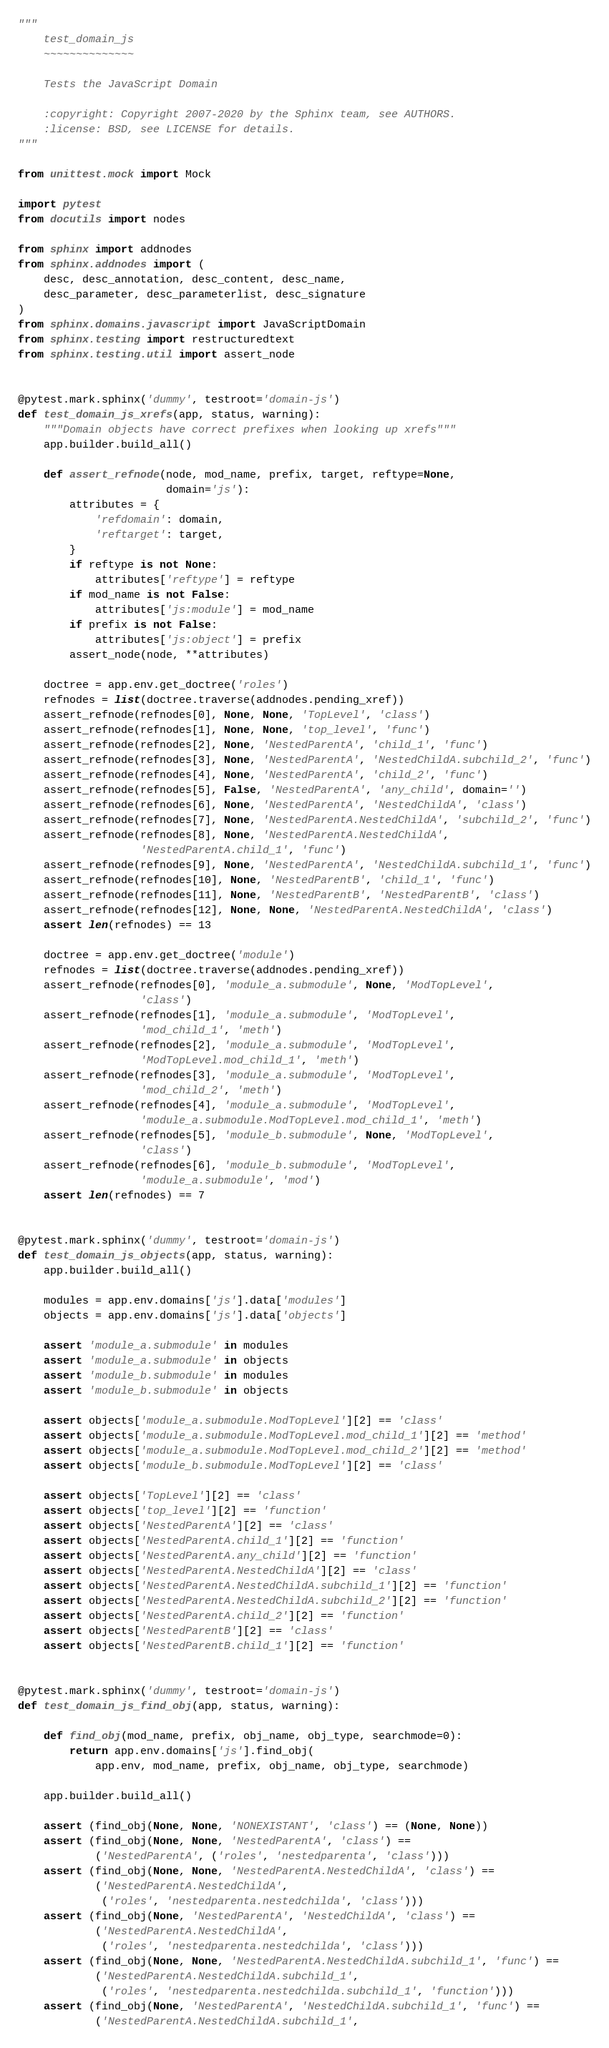<code> <loc_0><loc_0><loc_500><loc_500><_Python_>"""
    test_domain_js
    ~~~~~~~~~~~~~~

    Tests the JavaScript Domain

    :copyright: Copyright 2007-2020 by the Sphinx team, see AUTHORS.
    :license: BSD, see LICENSE for details.
"""

from unittest.mock import Mock

import pytest
from docutils import nodes

from sphinx import addnodes
from sphinx.addnodes import (
    desc, desc_annotation, desc_content, desc_name,
    desc_parameter, desc_parameterlist, desc_signature
)
from sphinx.domains.javascript import JavaScriptDomain
from sphinx.testing import restructuredtext
from sphinx.testing.util import assert_node


@pytest.mark.sphinx('dummy', testroot='domain-js')
def test_domain_js_xrefs(app, status, warning):
    """Domain objects have correct prefixes when looking up xrefs"""
    app.builder.build_all()

    def assert_refnode(node, mod_name, prefix, target, reftype=None,
                       domain='js'):
        attributes = {
            'refdomain': domain,
            'reftarget': target,
        }
        if reftype is not None:
            attributes['reftype'] = reftype
        if mod_name is not False:
            attributes['js:module'] = mod_name
        if prefix is not False:
            attributes['js:object'] = prefix
        assert_node(node, **attributes)

    doctree = app.env.get_doctree('roles')
    refnodes = list(doctree.traverse(addnodes.pending_xref))
    assert_refnode(refnodes[0], None, None, 'TopLevel', 'class')
    assert_refnode(refnodes[1], None, None, 'top_level', 'func')
    assert_refnode(refnodes[2], None, 'NestedParentA', 'child_1', 'func')
    assert_refnode(refnodes[3], None, 'NestedParentA', 'NestedChildA.subchild_2', 'func')
    assert_refnode(refnodes[4], None, 'NestedParentA', 'child_2', 'func')
    assert_refnode(refnodes[5], False, 'NestedParentA', 'any_child', domain='')
    assert_refnode(refnodes[6], None, 'NestedParentA', 'NestedChildA', 'class')
    assert_refnode(refnodes[7], None, 'NestedParentA.NestedChildA', 'subchild_2', 'func')
    assert_refnode(refnodes[8], None, 'NestedParentA.NestedChildA',
                   'NestedParentA.child_1', 'func')
    assert_refnode(refnodes[9], None, 'NestedParentA', 'NestedChildA.subchild_1', 'func')
    assert_refnode(refnodes[10], None, 'NestedParentB', 'child_1', 'func')
    assert_refnode(refnodes[11], None, 'NestedParentB', 'NestedParentB', 'class')
    assert_refnode(refnodes[12], None, None, 'NestedParentA.NestedChildA', 'class')
    assert len(refnodes) == 13

    doctree = app.env.get_doctree('module')
    refnodes = list(doctree.traverse(addnodes.pending_xref))
    assert_refnode(refnodes[0], 'module_a.submodule', None, 'ModTopLevel',
                   'class')
    assert_refnode(refnodes[1], 'module_a.submodule', 'ModTopLevel',
                   'mod_child_1', 'meth')
    assert_refnode(refnodes[2], 'module_a.submodule', 'ModTopLevel',
                   'ModTopLevel.mod_child_1', 'meth')
    assert_refnode(refnodes[3], 'module_a.submodule', 'ModTopLevel',
                   'mod_child_2', 'meth')
    assert_refnode(refnodes[4], 'module_a.submodule', 'ModTopLevel',
                   'module_a.submodule.ModTopLevel.mod_child_1', 'meth')
    assert_refnode(refnodes[5], 'module_b.submodule', None, 'ModTopLevel',
                   'class')
    assert_refnode(refnodes[6], 'module_b.submodule', 'ModTopLevel',
                   'module_a.submodule', 'mod')
    assert len(refnodes) == 7


@pytest.mark.sphinx('dummy', testroot='domain-js')
def test_domain_js_objects(app, status, warning):
    app.builder.build_all()

    modules = app.env.domains['js'].data['modules']
    objects = app.env.domains['js'].data['objects']

    assert 'module_a.submodule' in modules
    assert 'module_a.submodule' in objects
    assert 'module_b.submodule' in modules
    assert 'module_b.submodule' in objects

    assert objects['module_a.submodule.ModTopLevel'][2] == 'class'
    assert objects['module_a.submodule.ModTopLevel.mod_child_1'][2] == 'method'
    assert objects['module_a.submodule.ModTopLevel.mod_child_2'][2] == 'method'
    assert objects['module_b.submodule.ModTopLevel'][2] == 'class'

    assert objects['TopLevel'][2] == 'class'
    assert objects['top_level'][2] == 'function'
    assert objects['NestedParentA'][2] == 'class'
    assert objects['NestedParentA.child_1'][2] == 'function'
    assert objects['NestedParentA.any_child'][2] == 'function'
    assert objects['NestedParentA.NestedChildA'][2] == 'class'
    assert objects['NestedParentA.NestedChildA.subchild_1'][2] == 'function'
    assert objects['NestedParentA.NestedChildA.subchild_2'][2] == 'function'
    assert objects['NestedParentA.child_2'][2] == 'function'
    assert objects['NestedParentB'][2] == 'class'
    assert objects['NestedParentB.child_1'][2] == 'function'


@pytest.mark.sphinx('dummy', testroot='domain-js')
def test_domain_js_find_obj(app, status, warning):

    def find_obj(mod_name, prefix, obj_name, obj_type, searchmode=0):
        return app.env.domains['js'].find_obj(
            app.env, mod_name, prefix, obj_name, obj_type, searchmode)

    app.builder.build_all()

    assert (find_obj(None, None, 'NONEXISTANT', 'class') == (None, None))
    assert (find_obj(None, None, 'NestedParentA', 'class') ==
            ('NestedParentA', ('roles', 'nestedparenta', 'class')))
    assert (find_obj(None, None, 'NestedParentA.NestedChildA', 'class') ==
            ('NestedParentA.NestedChildA',
             ('roles', 'nestedparenta.nestedchilda', 'class')))
    assert (find_obj(None, 'NestedParentA', 'NestedChildA', 'class') ==
            ('NestedParentA.NestedChildA',
             ('roles', 'nestedparenta.nestedchilda', 'class')))
    assert (find_obj(None, None, 'NestedParentA.NestedChildA.subchild_1', 'func') ==
            ('NestedParentA.NestedChildA.subchild_1',
             ('roles', 'nestedparenta.nestedchilda.subchild_1', 'function')))
    assert (find_obj(None, 'NestedParentA', 'NestedChildA.subchild_1', 'func') ==
            ('NestedParentA.NestedChildA.subchild_1',</code> 